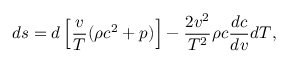Convert formula to latex. <formula><loc_0><loc_0><loc_500><loc_500>d s = d \left [ { \frac { v } { T } } ( \rho c ^ { 2 } + p ) \right ] - { \frac { 2 v ^ { 2 } } { T ^ { 2 } } } \rho c { \frac { d c } { d v } } d T ,</formula> 